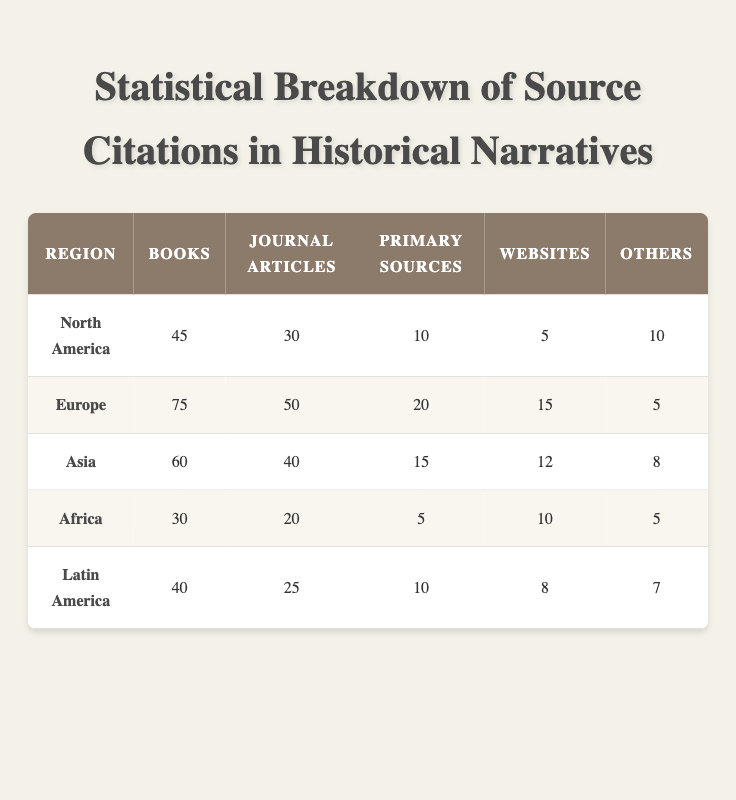What region has the highest number of journal article citations? By examining the table, we see that Europe has 50 journal article citations, which is greater than any other region listed. North America follows with 30, Asia with 40, Africa with 20, and Latin America with 25. Therefore, Europe is confirmed as having the highest number of journal article citations.
Answer: Europe How many total citations are there for Africa? The total citations for Africa can be calculated by summing the individual citation counts: 30 (Books) + 20 (Journal Articles) + 5 (Primary Sources) + 10 (Websites) + 5 (Others) = 70. Therefore, the total is 70 citations.
Answer: 70 Which region has the least number of primary source citations, and how many are there? In the table, Africa has 5 primary source citations, the lowest amount compared to all other regions. North America has 10, Europe has 20, Asia has 15, and Latin America has 10. Thus, Africa has the least primary source citations with a count of 5.
Answer: Africa, 5 What is the average number of website citations across all regions? To find the average number of website citations, we sum the amounts for each region: 5 (North America) + 15 (Europe) + 12 (Asia) + 10 (Africa) + 8 (Latin America) = 50. Then, we divide by the number of regions, which is 5: 50/5 = 10. Therefore, the average number of website citations is 10.
Answer: 10 Are there more book citations in Asia or Latin America? Asia has 60 book citations, while Latin America has 40. A direct comparison shows that Asia has more book citations than Latin America, making this a true statement.
Answer: Yes 